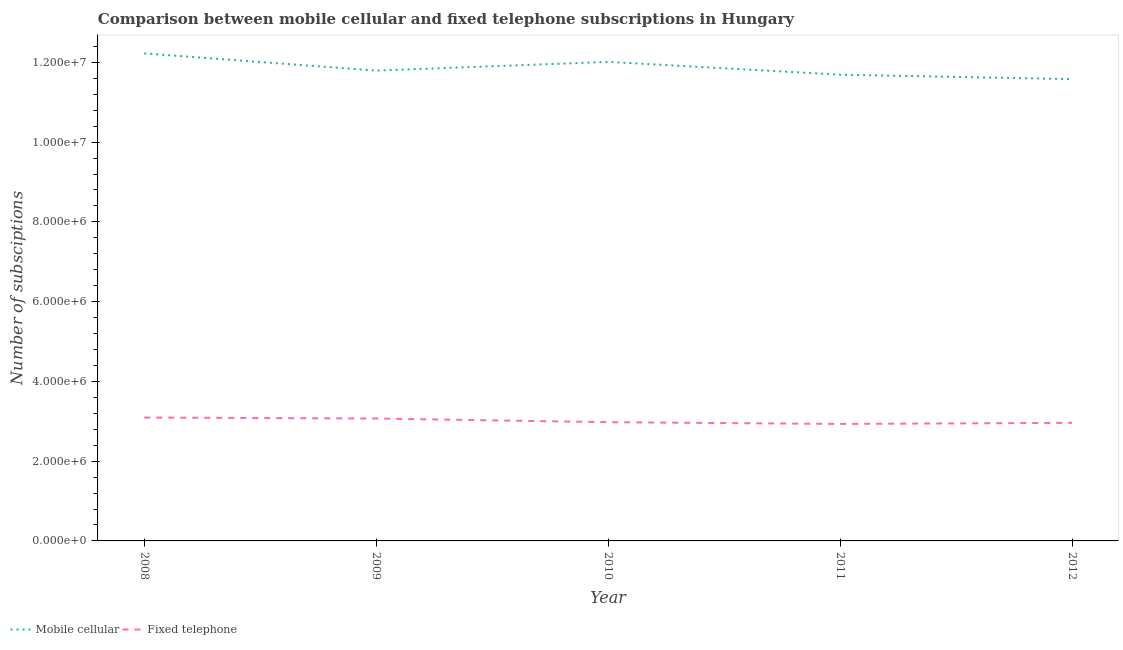Does the line corresponding to number of fixed telephone subscriptions intersect with the line corresponding to number of mobile cellular subscriptions?
Your answer should be compact. No. What is the number of fixed telephone subscriptions in 2011?
Give a very brief answer. 2.93e+06. Across all years, what is the maximum number of fixed telephone subscriptions?
Keep it short and to the point. 3.09e+06. Across all years, what is the minimum number of mobile cellular subscriptions?
Keep it short and to the point. 1.16e+07. In which year was the number of mobile cellular subscriptions minimum?
Offer a terse response. 2012. What is the total number of mobile cellular subscriptions in the graph?
Keep it short and to the point. 5.93e+07. What is the difference between the number of fixed telephone subscriptions in 2010 and that in 2012?
Provide a short and direct response. 1.66e+04. What is the difference between the number of mobile cellular subscriptions in 2012 and the number of fixed telephone subscriptions in 2011?
Provide a succinct answer. 8.65e+06. What is the average number of mobile cellular subscriptions per year?
Offer a terse response. 1.19e+07. In the year 2012, what is the difference between the number of fixed telephone subscriptions and number of mobile cellular subscriptions?
Ensure brevity in your answer.  -8.62e+06. What is the ratio of the number of mobile cellular subscriptions in 2009 to that in 2010?
Your answer should be compact. 0.98. What is the difference between the highest and the second highest number of mobile cellular subscriptions?
Your response must be concise. 2.12e+05. What is the difference between the highest and the lowest number of fixed telephone subscriptions?
Your answer should be very brief. 1.61e+05. In how many years, is the number of fixed telephone subscriptions greater than the average number of fixed telephone subscriptions taken over all years?
Keep it short and to the point. 2. Does the number of fixed telephone subscriptions monotonically increase over the years?
Your answer should be compact. No. Is the number of mobile cellular subscriptions strictly greater than the number of fixed telephone subscriptions over the years?
Offer a very short reply. Yes. What is the difference between two consecutive major ticks on the Y-axis?
Provide a short and direct response. 2.00e+06. Are the values on the major ticks of Y-axis written in scientific E-notation?
Offer a terse response. Yes. Where does the legend appear in the graph?
Your response must be concise. Bottom left. What is the title of the graph?
Ensure brevity in your answer.  Comparison between mobile cellular and fixed telephone subscriptions in Hungary. What is the label or title of the Y-axis?
Your response must be concise. Number of subsciptions. What is the Number of subsciptions in Mobile cellular in 2008?
Your answer should be very brief. 1.22e+07. What is the Number of subsciptions of Fixed telephone in 2008?
Your answer should be compact. 3.09e+06. What is the Number of subsciptions of Mobile cellular in 2009?
Provide a succinct answer. 1.18e+07. What is the Number of subsciptions of Fixed telephone in 2009?
Provide a succinct answer. 3.07e+06. What is the Number of subsciptions of Mobile cellular in 2010?
Your answer should be compact. 1.20e+07. What is the Number of subsciptions in Fixed telephone in 2010?
Offer a very short reply. 2.98e+06. What is the Number of subsciptions of Mobile cellular in 2011?
Your answer should be very brief. 1.17e+07. What is the Number of subsciptions of Fixed telephone in 2011?
Keep it short and to the point. 2.93e+06. What is the Number of subsciptions in Mobile cellular in 2012?
Provide a short and direct response. 1.16e+07. What is the Number of subsciptions in Fixed telephone in 2012?
Provide a short and direct response. 2.96e+06. Across all years, what is the maximum Number of subsciptions of Mobile cellular?
Provide a short and direct response. 1.22e+07. Across all years, what is the maximum Number of subsciptions in Fixed telephone?
Your answer should be compact. 3.09e+06. Across all years, what is the minimum Number of subsciptions in Mobile cellular?
Provide a short and direct response. 1.16e+07. Across all years, what is the minimum Number of subsciptions of Fixed telephone?
Give a very brief answer. 2.93e+06. What is the total Number of subsciptions in Mobile cellular in the graph?
Ensure brevity in your answer.  5.93e+07. What is the total Number of subsciptions in Fixed telephone in the graph?
Give a very brief answer. 1.50e+07. What is the difference between the Number of subsciptions in Mobile cellular in 2008 and that in 2009?
Give a very brief answer. 4.32e+05. What is the difference between the Number of subsciptions of Fixed telephone in 2008 and that in 2009?
Your response must be concise. 2.53e+04. What is the difference between the Number of subsciptions in Mobile cellular in 2008 and that in 2010?
Keep it short and to the point. 2.12e+05. What is the difference between the Number of subsciptions in Fixed telephone in 2008 and that in 2010?
Provide a short and direct response. 1.17e+05. What is the difference between the Number of subsciptions in Mobile cellular in 2008 and that in 2011?
Your answer should be compact. 5.34e+05. What is the difference between the Number of subsciptions of Fixed telephone in 2008 and that in 2011?
Provide a succinct answer. 1.61e+05. What is the difference between the Number of subsciptions in Mobile cellular in 2008 and that in 2012?
Your answer should be very brief. 6.45e+05. What is the difference between the Number of subsciptions in Fixed telephone in 2008 and that in 2012?
Offer a terse response. 1.33e+05. What is the difference between the Number of subsciptions in Mobile cellular in 2009 and that in 2010?
Provide a succinct answer. -2.19e+05. What is the difference between the Number of subsciptions in Fixed telephone in 2009 and that in 2010?
Provide a short and direct response. 9.15e+04. What is the difference between the Number of subsciptions in Mobile cellular in 2009 and that in 2011?
Provide a short and direct response. 1.03e+05. What is the difference between the Number of subsciptions of Fixed telephone in 2009 and that in 2011?
Keep it short and to the point. 1.35e+05. What is the difference between the Number of subsciptions in Mobile cellular in 2009 and that in 2012?
Offer a very short reply. 2.13e+05. What is the difference between the Number of subsciptions in Fixed telephone in 2009 and that in 2012?
Your answer should be compact. 1.08e+05. What is the difference between the Number of subsciptions in Mobile cellular in 2010 and that in 2011?
Keep it short and to the point. 3.22e+05. What is the difference between the Number of subsciptions in Fixed telephone in 2010 and that in 2011?
Provide a short and direct response. 4.39e+04. What is the difference between the Number of subsciptions in Mobile cellular in 2010 and that in 2012?
Provide a short and direct response. 4.32e+05. What is the difference between the Number of subsciptions of Fixed telephone in 2010 and that in 2012?
Offer a terse response. 1.66e+04. What is the difference between the Number of subsciptions of Mobile cellular in 2011 and that in 2012?
Provide a short and direct response. 1.11e+05. What is the difference between the Number of subsciptions in Fixed telephone in 2011 and that in 2012?
Your response must be concise. -2.73e+04. What is the difference between the Number of subsciptions of Mobile cellular in 2008 and the Number of subsciptions of Fixed telephone in 2009?
Your response must be concise. 9.16e+06. What is the difference between the Number of subsciptions in Mobile cellular in 2008 and the Number of subsciptions in Fixed telephone in 2010?
Offer a terse response. 9.25e+06. What is the difference between the Number of subsciptions in Mobile cellular in 2008 and the Number of subsciptions in Fixed telephone in 2011?
Make the answer very short. 9.29e+06. What is the difference between the Number of subsciptions in Mobile cellular in 2008 and the Number of subsciptions in Fixed telephone in 2012?
Ensure brevity in your answer.  9.26e+06. What is the difference between the Number of subsciptions of Mobile cellular in 2009 and the Number of subsciptions of Fixed telephone in 2010?
Your answer should be very brief. 8.82e+06. What is the difference between the Number of subsciptions of Mobile cellular in 2009 and the Number of subsciptions of Fixed telephone in 2011?
Give a very brief answer. 8.86e+06. What is the difference between the Number of subsciptions of Mobile cellular in 2009 and the Number of subsciptions of Fixed telephone in 2012?
Give a very brief answer. 8.83e+06. What is the difference between the Number of subsciptions in Mobile cellular in 2010 and the Number of subsciptions in Fixed telephone in 2011?
Your answer should be compact. 9.08e+06. What is the difference between the Number of subsciptions of Mobile cellular in 2010 and the Number of subsciptions of Fixed telephone in 2012?
Make the answer very short. 9.05e+06. What is the difference between the Number of subsciptions in Mobile cellular in 2011 and the Number of subsciptions in Fixed telephone in 2012?
Offer a very short reply. 8.73e+06. What is the average Number of subsciptions in Mobile cellular per year?
Your answer should be very brief. 1.19e+07. What is the average Number of subsciptions in Fixed telephone per year?
Your response must be concise. 3.01e+06. In the year 2008, what is the difference between the Number of subsciptions of Mobile cellular and Number of subsciptions of Fixed telephone?
Offer a very short reply. 9.13e+06. In the year 2009, what is the difference between the Number of subsciptions in Mobile cellular and Number of subsciptions in Fixed telephone?
Your answer should be very brief. 8.72e+06. In the year 2010, what is the difference between the Number of subsciptions of Mobile cellular and Number of subsciptions of Fixed telephone?
Your response must be concise. 9.03e+06. In the year 2011, what is the difference between the Number of subsciptions of Mobile cellular and Number of subsciptions of Fixed telephone?
Your answer should be very brief. 8.76e+06. In the year 2012, what is the difference between the Number of subsciptions of Mobile cellular and Number of subsciptions of Fixed telephone?
Your response must be concise. 8.62e+06. What is the ratio of the Number of subsciptions of Mobile cellular in 2008 to that in 2009?
Provide a short and direct response. 1.04. What is the ratio of the Number of subsciptions of Fixed telephone in 2008 to that in 2009?
Make the answer very short. 1.01. What is the ratio of the Number of subsciptions of Mobile cellular in 2008 to that in 2010?
Provide a short and direct response. 1.02. What is the ratio of the Number of subsciptions in Fixed telephone in 2008 to that in 2010?
Keep it short and to the point. 1.04. What is the ratio of the Number of subsciptions in Mobile cellular in 2008 to that in 2011?
Your response must be concise. 1.05. What is the ratio of the Number of subsciptions of Fixed telephone in 2008 to that in 2011?
Provide a succinct answer. 1.05. What is the ratio of the Number of subsciptions in Mobile cellular in 2008 to that in 2012?
Offer a terse response. 1.06. What is the ratio of the Number of subsciptions in Fixed telephone in 2008 to that in 2012?
Your answer should be compact. 1.04. What is the ratio of the Number of subsciptions in Mobile cellular in 2009 to that in 2010?
Your answer should be compact. 0.98. What is the ratio of the Number of subsciptions of Fixed telephone in 2009 to that in 2010?
Offer a very short reply. 1.03. What is the ratio of the Number of subsciptions in Mobile cellular in 2009 to that in 2011?
Your answer should be very brief. 1.01. What is the ratio of the Number of subsciptions in Fixed telephone in 2009 to that in 2011?
Offer a very short reply. 1.05. What is the ratio of the Number of subsciptions of Mobile cellular in 2009 to that in 2012?
Your response must be concise. 1.02. What is the ratio of the Number of subsciptions of Fixed telephone in 2009 to that in 2012?
Your answer should be compact. 1.04. What is the ratio of the Number of subsciptions of Mobile cellular in 2010 to that in 2011?
Keep it short and to the point. 1.03. What is the ratio of the Number of subsciptions of Fixed telephone in 2010 to that in 2011?
Your answer should be compact. 1.01. What is the ratio of the Number of subsciptions of Mobile cellular in 2010 to that in 2012?
Provide a short and direct response. 1.04. What is the ratio of the Number of subsciptions in Fixed telephone in 2010 to that in 2012?
Your answer should be compact. 1.01. What is the ratio of the Number of subsciptions in Mobile cellular in 2011 to that in 2012?
Keep it short and to the point. 1.01. What is the ratio of the Number of subsciptions of Fixed telephone in 2011 to that in 2012?
Offer a very short reply. 0.99. What is the difference between the highest and the second highest Number of subsciptions of Mobile cellular?
Your response must be concise. 2.12e+05. What is the difference between the highest and the second highest Number of subsciptions in Fixed telephone?
Offer a terse response. 2.53e+04. What is the difference between the highest and the lowest Number of subsciptions in Mobile cellular?
Your answer should be very brief. 6.45e+05. What is the difference between the highest and the lowest Number of subsciptions in Fixed telephone?
Offer a very short reply. 1.61e+05. 